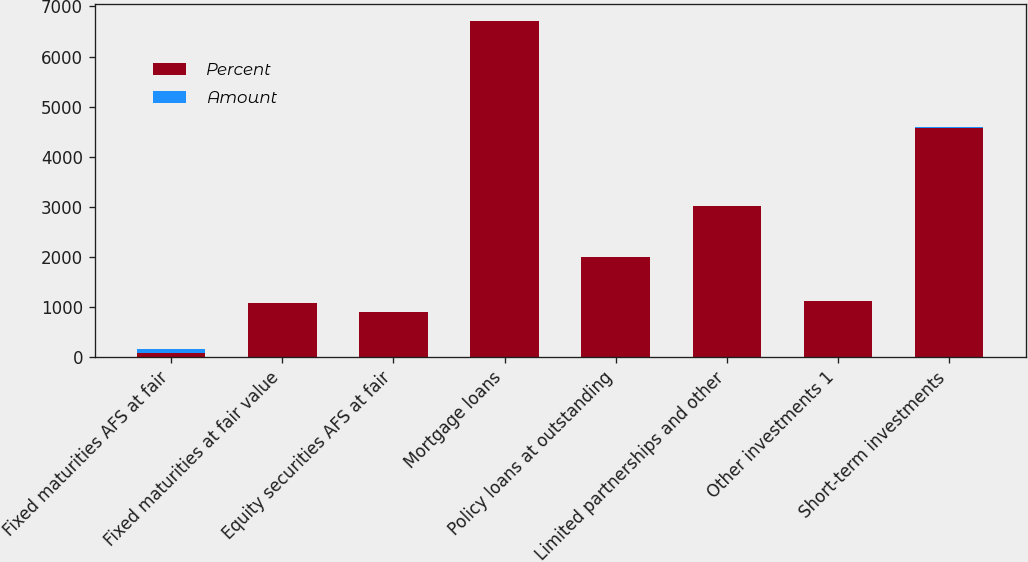Convert chart. <chart><loc_0><loc_0><loc_500><loc_500><stacked_bar_chart><ecel><fcel>Fixed maturities AFS at fair<fcel>Fixed maturities at fair value<fcel>Equity securities AFS at fair<fcel>Mortgage loans<fcel>Policy loans at outstanding<fcel>Limited partnerships and other<fcel>Other investments 1<fcel>Short-term investments<nl><fcel>Percent<fcel>81.6<fcel>1087<fcel>890<fcel>6711<fcel>1997<fcel>3015<fcel>1114<fcel>4581<nl><fcel>Amount<fcel>81.6<fcel>1<fcel>0.8<fcel>6.4<fcel>1.9<fcel>2.9<fcel>1.1<fcel>4.3<nl></chart> 